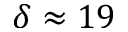Convert formula to latex. <formula><loc_0><loc_0><loc_500><loc_500>\delta \approx 1 9</formula> 